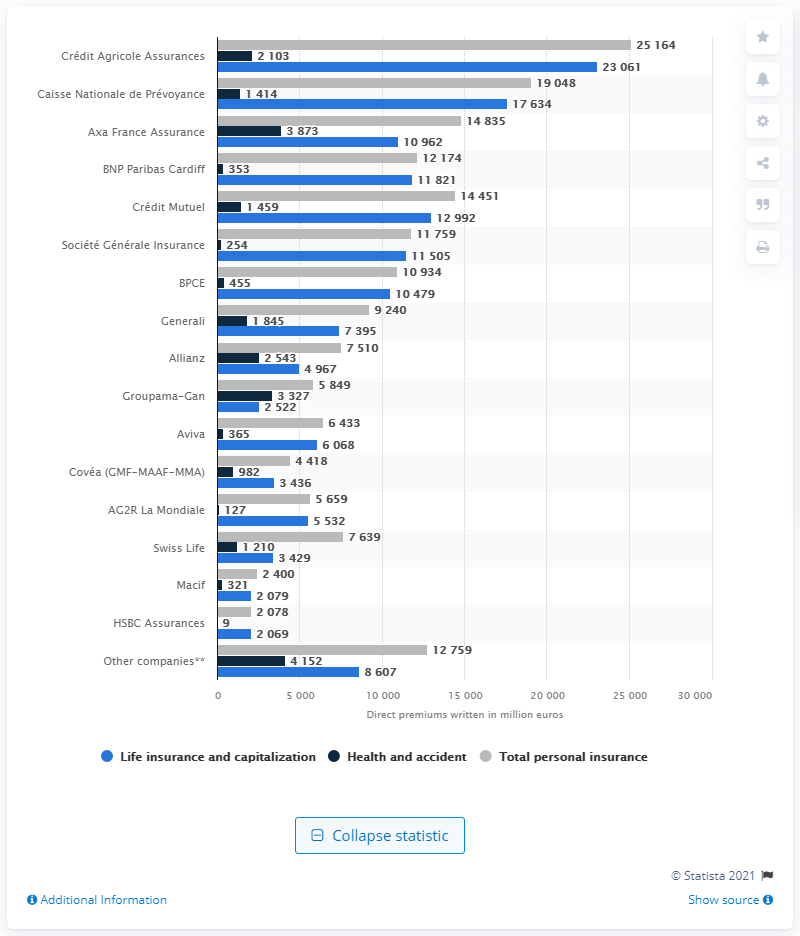Draw attention to some important aspects in this diagram. The premiums of Axa France Assurance in 2019 were approximately 14,835. 